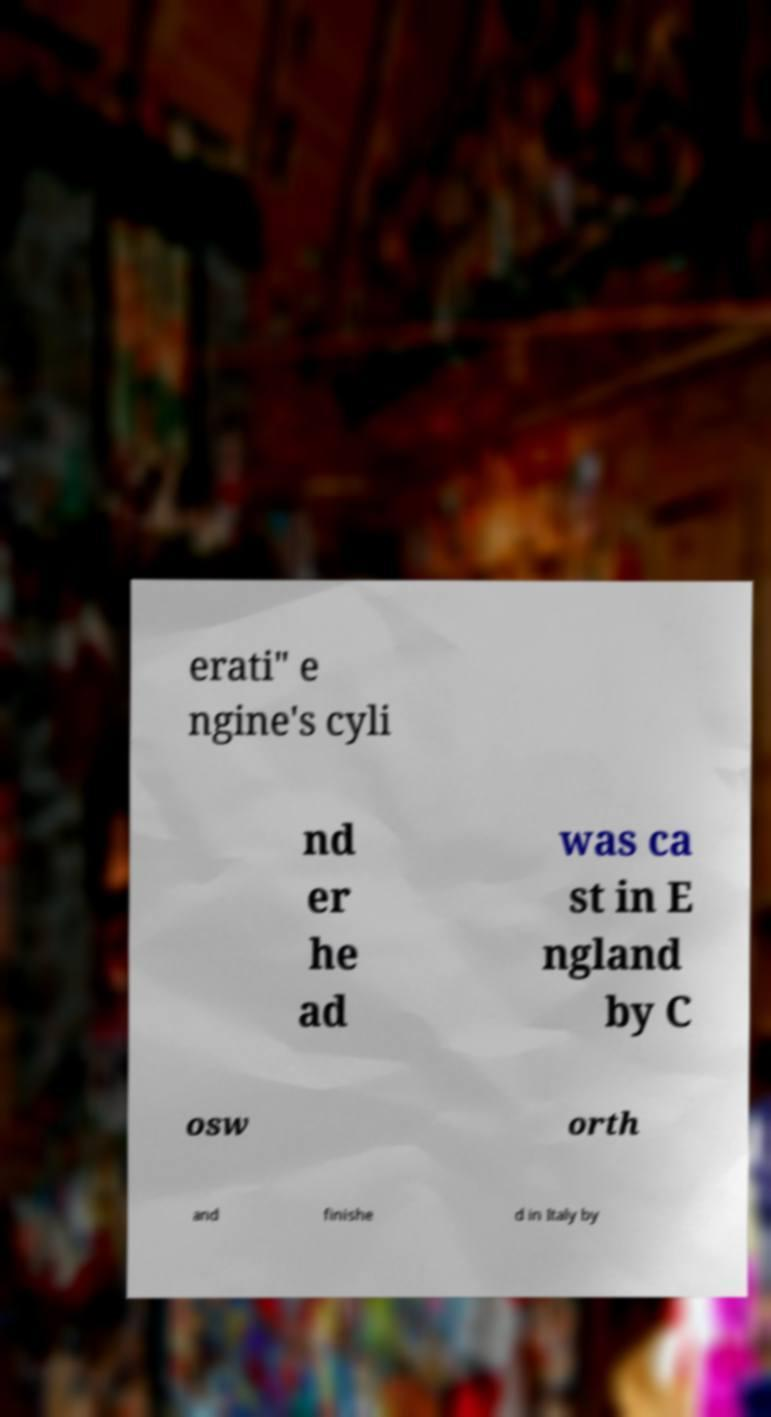Please read and relay the text visible in this image. What does it say? erati" e ngine's cyli nd er he ad was ca st in E ngland by C osw orth and finishe d in Italy by 